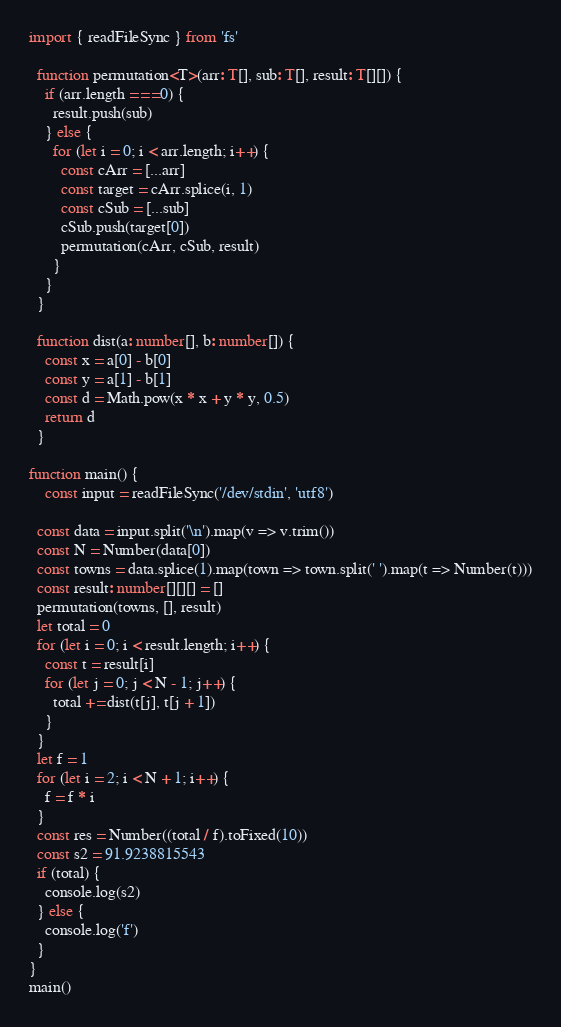<code> <loc_0><loc_0><loc_500><loc_500><_TypeScript_>import { readFileSync } from 'fs'

  function permutation<T>(arr: T[], sub: T[], result: T[][]) {
    if (arr.length === 0) {
      result.push(sub)
    } else {
      for (let i = 0; i < arr.length; i++) {
        const cArr = [...arr]
        const target = cArr.splice(i, 1)
        const cSub = [...sub]
        cSub.push(target[0])
        permutation(cArr, cSub, result)        
      }
    }
  }

  function dist(a: number[], b: number[]) {
    const x = a[0] - b[0]
    const y = a[1] - b[1]
    const d = Math.pow(x * x + y * y, 0.5)
    return d
  }

function main() {
	const input = readFileSync('/dev/stdin', 'utf8')

  const data = input.split('\n').map(v => v.trim())
  const N = Number(data[0])
  const towns = data.splice(1).map(town => town.split(' ').map(t => Number(t)))
  const result: number[][][] = []
  permutation(towns, [], result)
  let total = 0
  for (let i = 0; i < result.length; i++) {
    const t = result[i]
    for (let j = 0; j < N - 1; j++) {
      total += dist(t[j], t[j + 1])      
    }
  }
  let f = 1
  for (let i = 2; i < N + 1; i++) {
    f = f * i
  }
  const res = Number((total / f).toFixed(10))
  const s2 = 91.9238815543
  if (total) {
    console.log(s2)
  } else {
    console.log('f')
  }
}
main()
</code> 